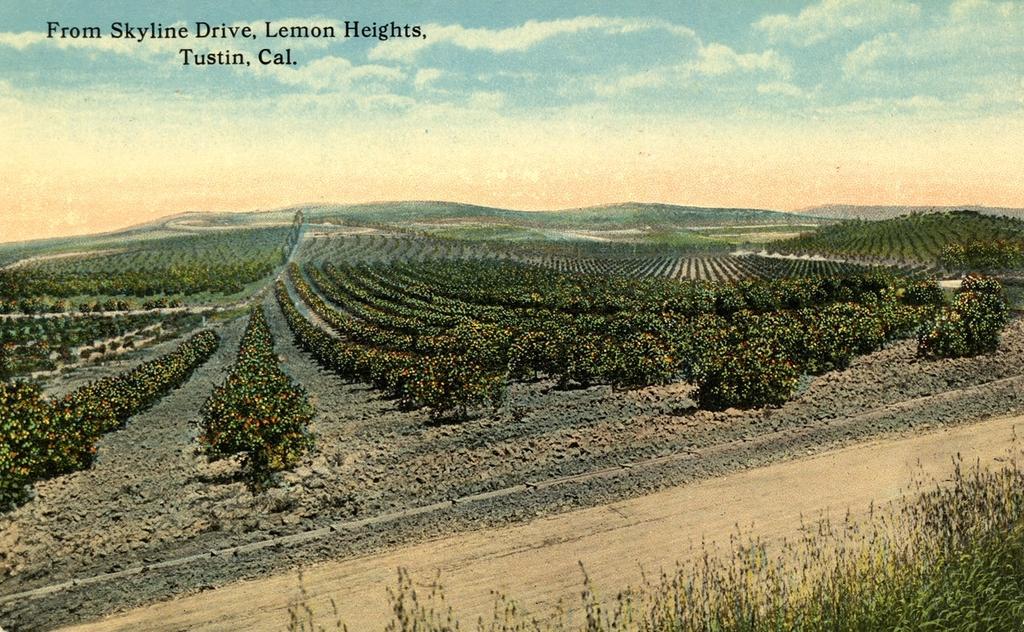In one or two sentences, can you explain what this image depicts? In this image there is the sky towards the top of the image, there are clouds in the sky, there are mountains, there are plants on the ground, there are plants towards the bottom of the image, there is text towards the top of the image. 